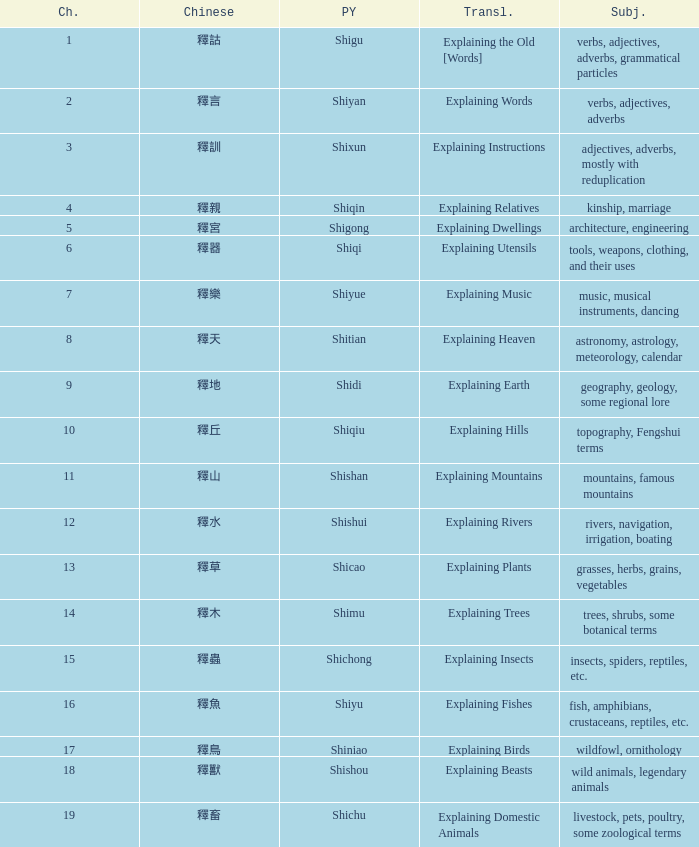Can you parse all the data within this table? {'header': ['Ch.', 'Chinese', 'PY', 'Transl.', 'Subj.'], 'rows': [['1', '釋詁', 'Shigu', 'Explaining the Old [Words]', 'verbs, adjectives, adverbs, grammatical particles'], ['2', '釋言', 'Shiyan', 'Explaining Words', 'verbs, adjectives, adverbs'], ['3', '釋訓', 'Shixun', 'Explaining Instructions', 'adjectives, adverbs, mostly with reduplication'], ['4', '釋親', 'Shiqin', 'Explaining Relatives', 'kinship, marriage'], ['5', '釋宮', 'Shigong', 'Explaining Dwellings', 'architecture, engineering'], ['6', '釋器', 'Shiqi', 'Explaining Utensils', 'tools, weapons, clothing, and their uses'], ['7', '釋樂', 'Shiyue', 'Explaining Music', 'music, musical instruments, dancing'], ['8', '釋天', 'Shitian', 'Explaining Heaven', 'astronomy, astrology, meteorology, calendar'], ['9', '釋地', 'Shidi', 'Explaining Earth', 'geography, geology, some regional lore'], ['10', '釋丘', 'Shiqiu', 'Explaining Hills', 'topography, Fengshui terms'], ['11', '釋山', 'Shishan', 'Explaining Mountains', 'mountains, famous mountains'], ['12', '釋水', 'Shishui', 'Explaining Rivers', 'rivers, navigation, irrigation, boating'], ['13', '釋草', 'Shicao', 'Explaining Plants', 'grasses, herbs, grains, vegetables'], ['14', '釋木', 'Shimu', 'Explaining Trees', 'trees, shrubs, some botanical terms'], ['15', '釋蟲', 'Shichong', 'Explaining Insects', 'insects, spiders, reptiles, etc.'], ['16', '釋魚', 'Shiyu', 'Explaining Fishes', 'fish, amphibians, crustaceans, reptiles, etc.'], ['17', '釋鳥', 'Shiniao', 'Explaining Birds', 'wildfowl, ornithology'], ['18', '釋獸', 'Shishou', 'Explaining Beasts', 'wild animals, legendary animals'], ['19', '釋畜', 'Shichu', 'Explaining Domestic Animals', 'livestock, pets, poultry, some zoological terms']]} Name the subject of shiyan Verbs, adjectives, adverbs. 